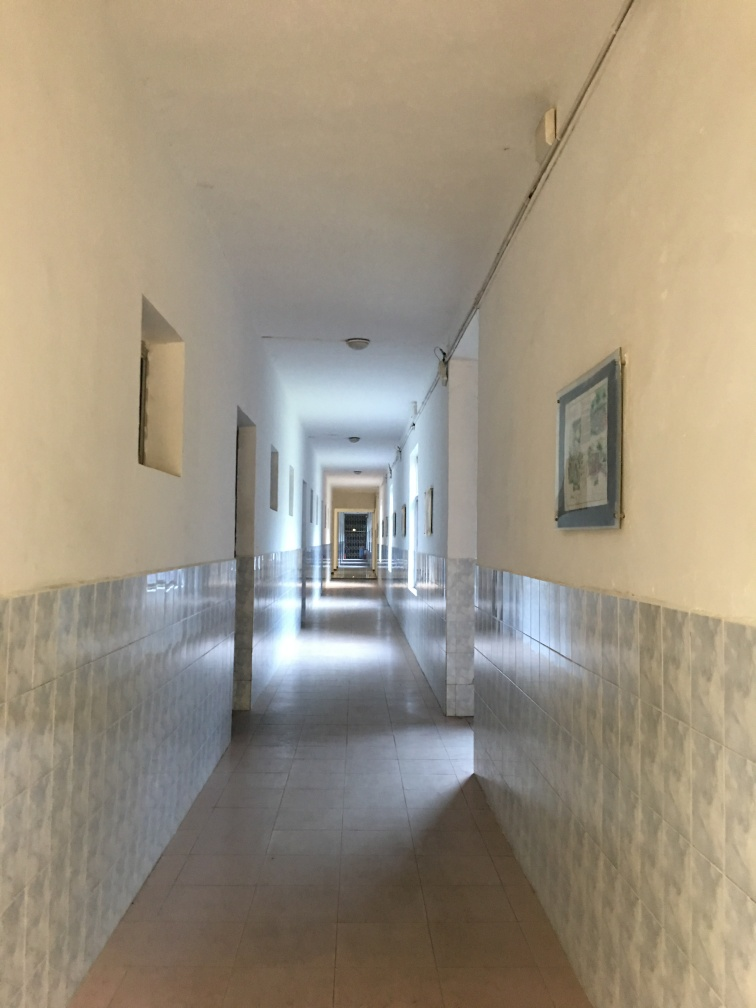What time of day do you think this photo was taken? Given the quality of the light and the angle of the shadows, it appears that the photo may have been taken in the morning when the sun is at a low angle, diffusing soft light throughout the corridor. 